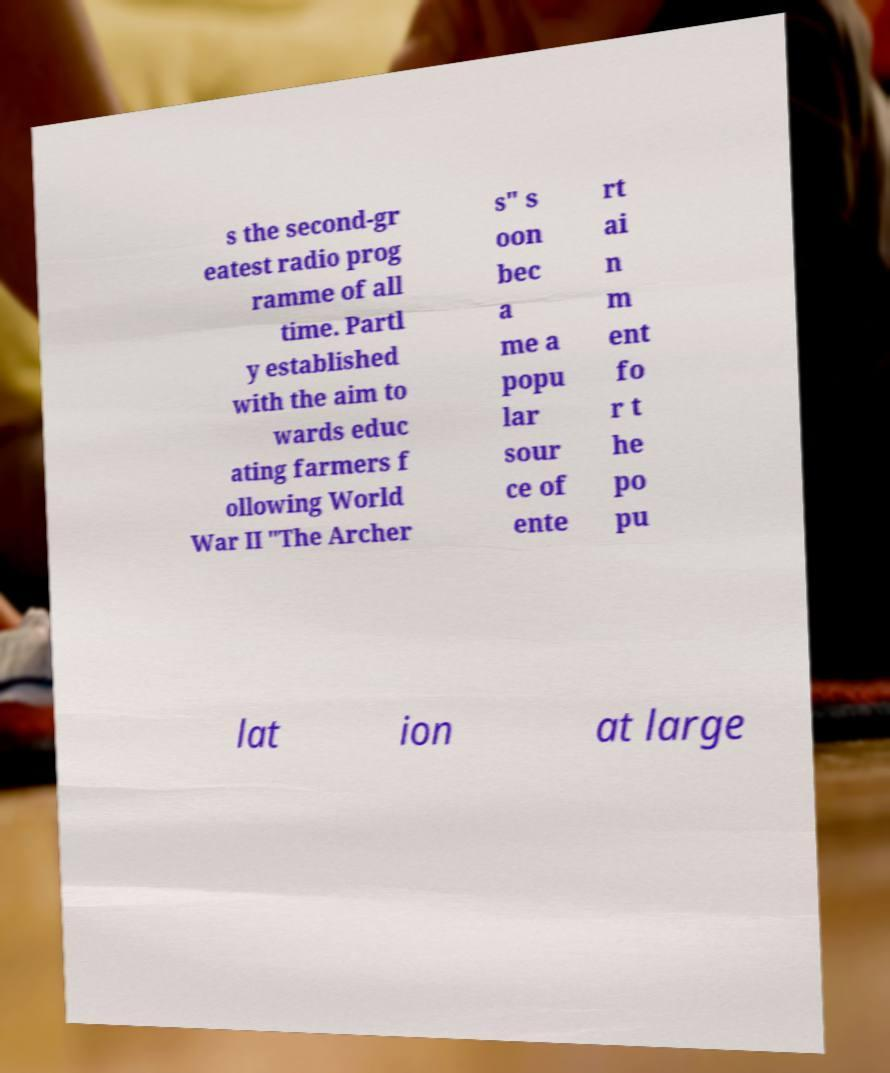For documentation purposes, I need the text within this image transcribed. Could you provide that? s the second-gr eatest radio prog ramme of all time. Partl y established with the aim to wards educ ating farmers f ollowing World War II "The Archer s" s oon bec a me a popu lar sour ce of ente rt ai n m ent fo r t he po pu lat ion at large 